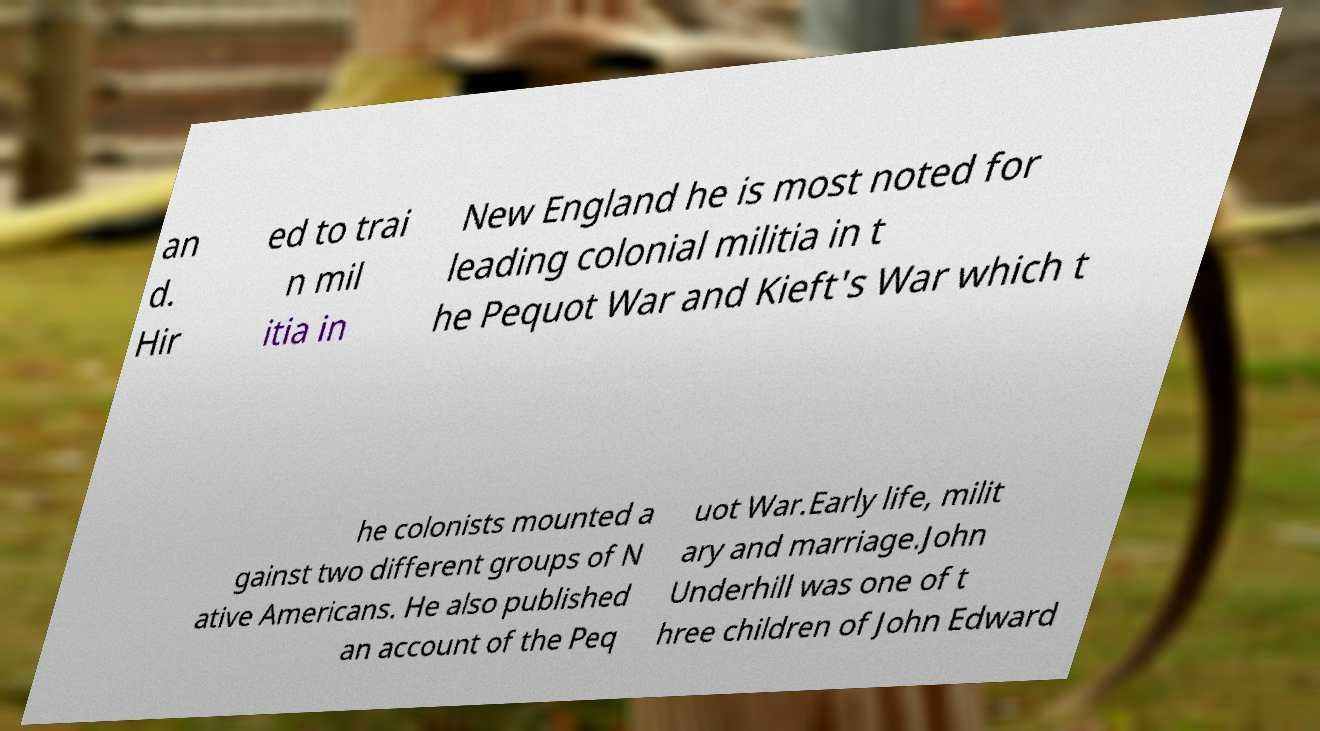There's text embedded in this image that I need extracted. Can you transcribe it verbatim? an d. Hir ed to trai n mil itia in New England he is most noted for leading colonial militia in t he Pequot War and Kieft's War which t he colonists mounted a gainst two different groups of N ative Americans. He also published an account of the Peq uot War.Early life, milit ary and marriage.John Underhill was one of t hree children of John Edward 